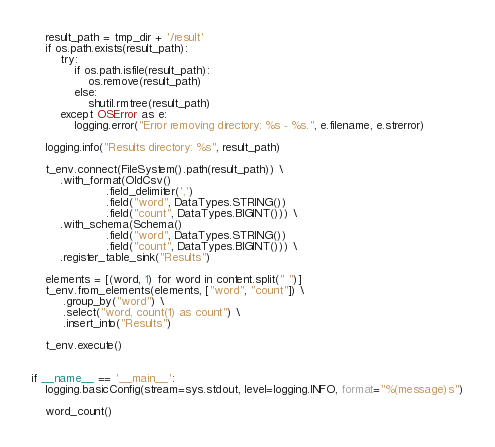Convert code to text. <code><loc_0><loc_0><loc_500><loc_500><_Python_>    result_path = tmp_dir + '/result'
    if os.path.exists(result_path):
        try:
            if os.path.isfile(result_path):
                os.remove(result_path)
            else:
                shutil.rmtree(result_path)
        except OSError as e:
            logging.error("Error removing directory: %s - %s.", e.filename, e.strerror)

    logging.info("Results directory: %s", result_path)

    t_env.connect(FileSystem().path(result_path)) \
        .with_format(OldCsv()
                     .field_delimiter(',')
                     .field("word", DataTypes.STRING())
                     .field("count", DataTypes.BIGINT())) \
        .with_schema(Schema()
                     .field("word", DataTypes.STRING())
                     .field("count", DataTypes.BIGINT())) \
        .register_table_sink("Results")

    elements = [(word, 1) for word in content.split(" ")]
    t_env.from_elements(elements, ["word", "count"]) \
         .group_by("word") \
         .select("word, count(1) as count") \
         .insert_into("Results")

    t_env.execute()


if __name__ == '__main__':
    logging.basicConfig(stream=sys.stdout, level=logging.INFO, format="%(message)s")

    word_count()
</code> 